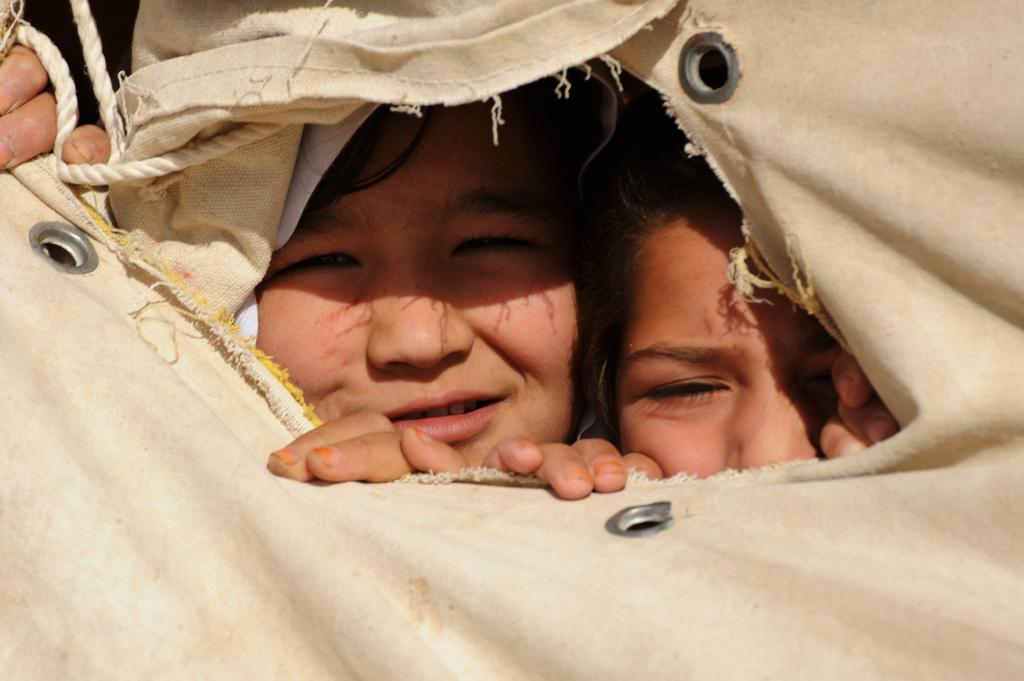How many people are in the image? There are two people in the image. What are the people doing in the image? The people are peeking out through cloth, which may be eyelets. Can you describe any other objects in the image? There appears to be a rope in the image. What type of insurance policy do the people in the image have? There is no information about insurance policies in the image, as it focuses on the people peeking out through cloth and the presence of a rope. 